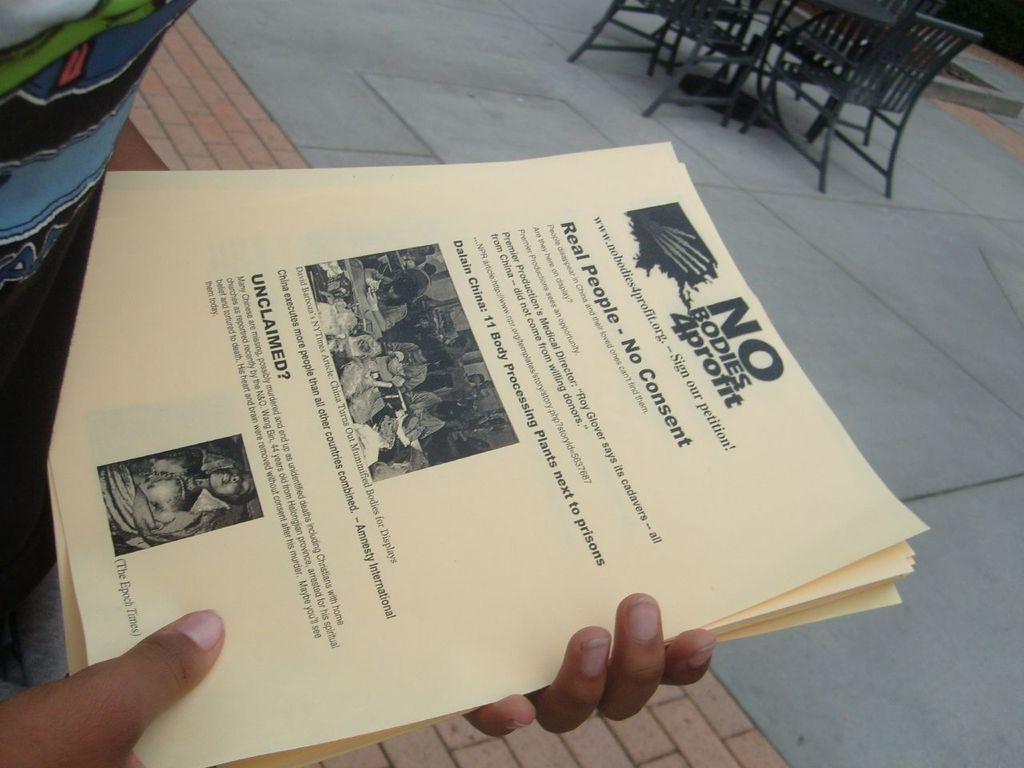Provide a one-sentence caption for the provided image. Flyers for No Bodies 4 Profit mention 11 body processing plants next to prisons. 